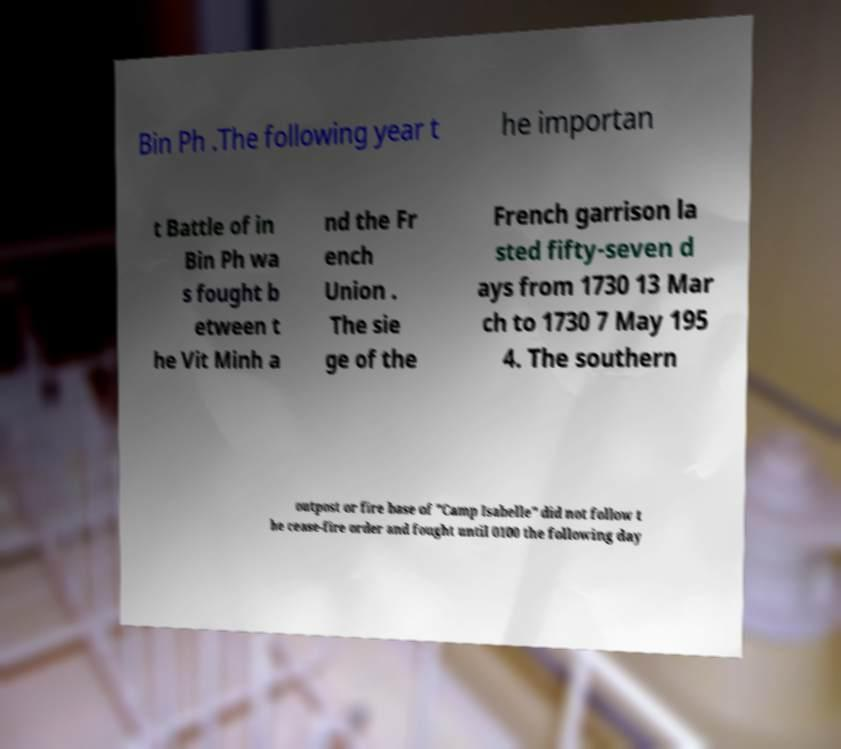For documentation purposes, I need the text within this image transcribed. Could you provide that? Bin Ph .The following year t he importan t Battle of in Bin Ph wa s fought b etween t he Vit Minh a nd the Fr ench Union . The sie ge of the French garrison la sted fifty-seven d ays from 1730 13 Mar ch to 1730 7 May 195 4. The southern outpost or fire base of "Camp Isabelle" did not follow t he cease-fire order and fought until 0100 the following day 